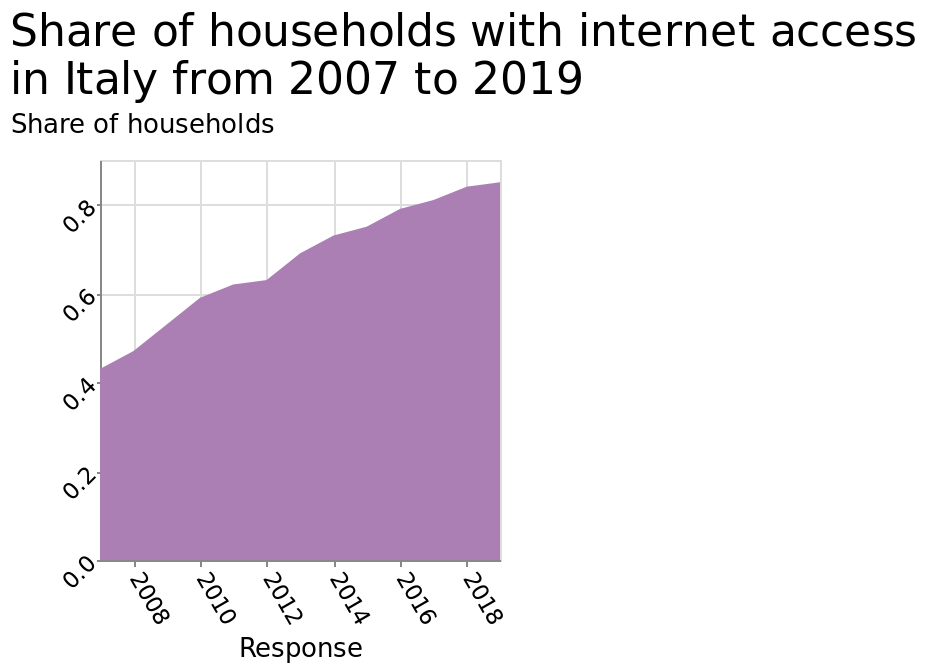<image>
What percentage of households had Internet prior to 2008? 40% What was the change in Internet adoption rate between 2008 and 2018? The Internet adoption rate increased significantly from 40% to above 80% during this time period. please summary the statistics and relations of the chart Internet access has doubled in the last 10 years. There was a slight drop in the share of houses that had internet access in 2012. The share of households in increasing over time. 